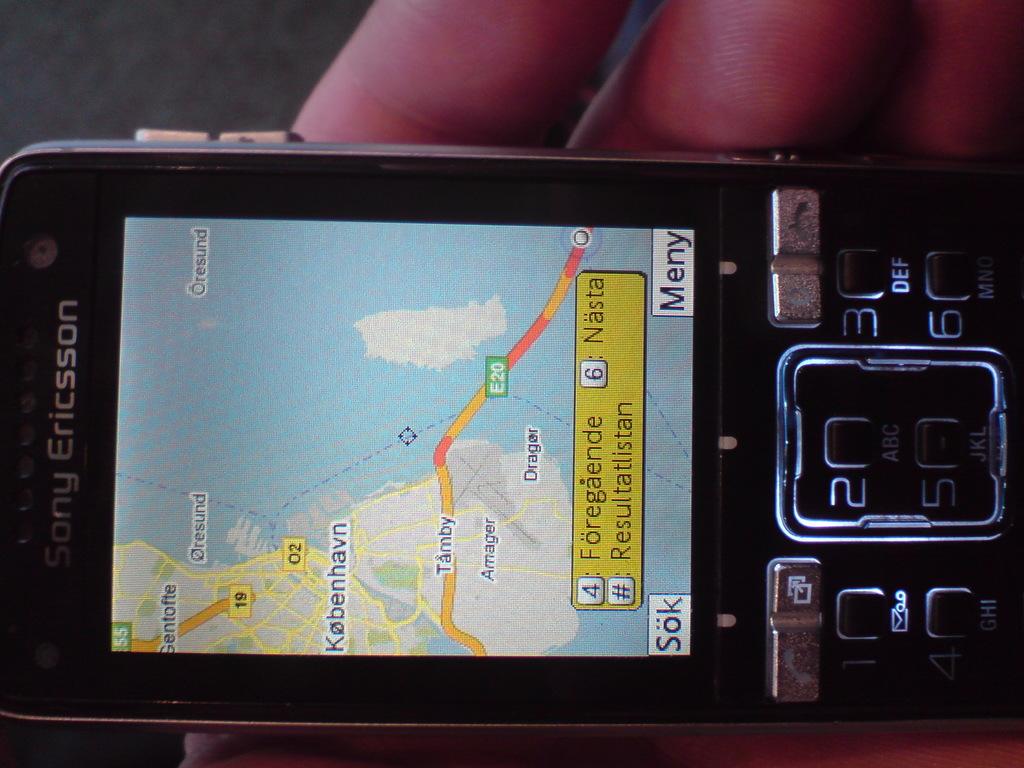Who manufacturered this phone?
Make the answer very short. Sony ericsson. What numbers have a box around them?
Ensure brevity in your answer.  4 and 6. 